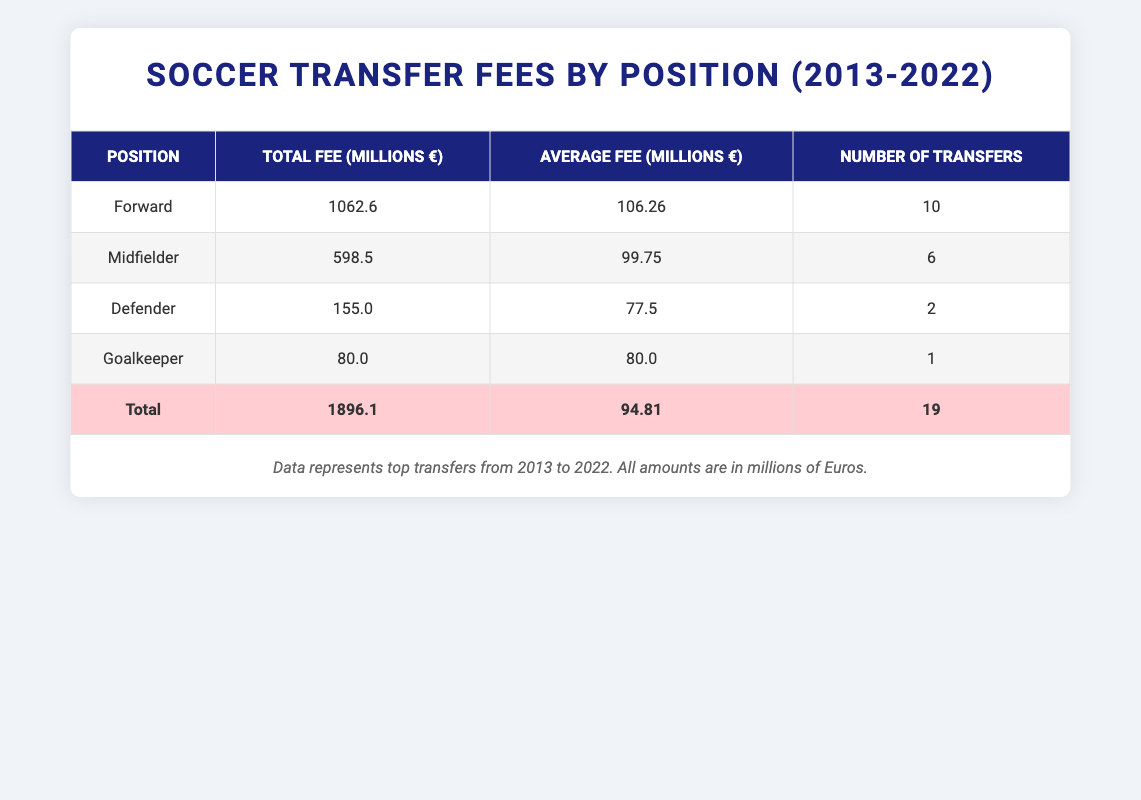What is the total transfer fee for all forwards? The total fee for all forwards is found in the table under the "Total Fee" column for the "Forward" position, which states 1062.6 million €
Answer: 1062.6 million € How many transfers were categorized as defenders? Referring to the "Number of Transfers" column for the "Defender" position, it indicates there were 2 transfers
Answer: 2 What is the average transfer fee for midfielders? To calculate this, we refer to the "Average Fee" column for the "Midfielder" position, which is 99.75 million €
Answer: 99.75 million € Did any goalkeepers have a higher transfer fee than 80 million €? Yes, there were no goalkeepers listed with a fee higher than 80 million € as there's only one goalkeeper in the table with an exact fee of 80 million €
Answer: No What is the difference in total transfer fees between forwards and midfielders? The total fee for forwards is 1062.6 million €, and for midfielders, it is 598.5 million €. The difference is calculated by subtracting the midfielder total from the forward total: 1062.6 - 598.5 = 464.1 million €
Answer: 464.1 million € What percentage of the total transfer fees came from defenders? The total transfer fee for defenders is 155.0 million €, and the overall total fee is 1896.1 million €. To find the percentage, we calculate (155.0 / 1896.1) * 100, which is approximately 8.17%
Answer: 8.17% Which position had the lowest average transfer fee? By comparing the "Average Fee" values across all positions in the table, the "Defender" position shows the lowest average fee of 77.5 million €
Answer: Defender How many total transfers occurred in the decade represented in the table? The total number of transfers can be directly obtained from the "Number of Transfers" row under "Total," which states 19 transfers occurred
Answer: 19 